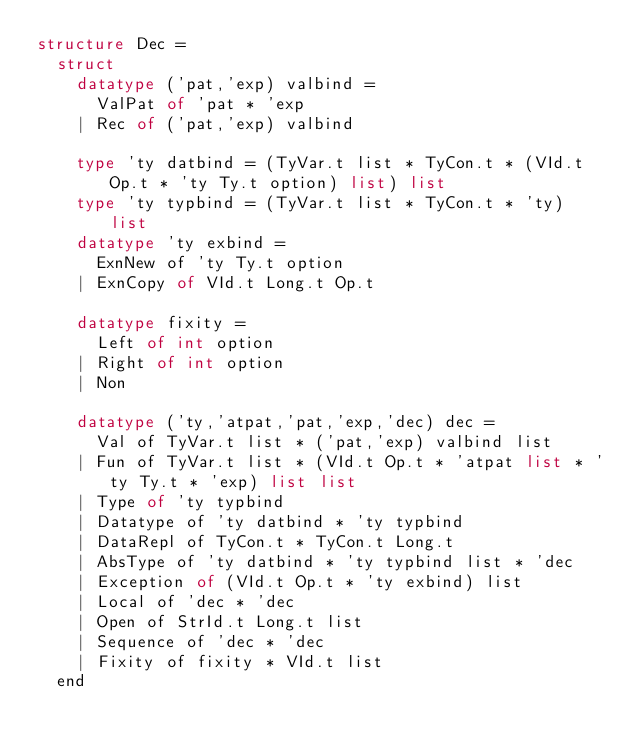Convert code to text. <code><loc_0><loc_0><loc_500><loc_500><_SML_>structure Dec =
  struct
    datatype ('pat,'exp) valbind =
      ValPat of 'pat * 'exp
    | Rec of ('pat,'exp) valbind

    type 'ty datbind = (TyVar.t list * TyCon.t * (VId.t Op.t * 'ty Ty.t option) list) list
    type 'ty typbind = (TyVar.t list * TyCon.t * 'ty) list
    datatype 'ty exbind =
      ExnNew of 'ty Ty.t option
    | ExnCopy of VId.t Long.t Op.t

    datatype fixity =
      Left of int option
    | Right of int option
    | Non

    datatype ('ty,'atpat,'pat,'exp,'dec) dec =
      Val of TyVar.t list * ('pat,'exp) valbind list
    | Fun of TyVar.t list * (VId.t Op.t * 'atpat list * 'ty Ty.t * 'exp) list list
    | Type of 'ty typbind
    | Datatype of 'ty datbind * 'ty typbind
    | DataRepl of TyCon.t * TyCon.t Long.t
    | AbsType of 'ty datbind * 'ty typbind list * 'dec
    | Exception of (VId.t Op.t * 'ty exbind) list
    | Local of 'dec * 'dec
    | Open of StrId.t Long.t list
    | Sequence of 'dec * 'dec
    | Fixity of fixity * VId.t list
  end
</code> 